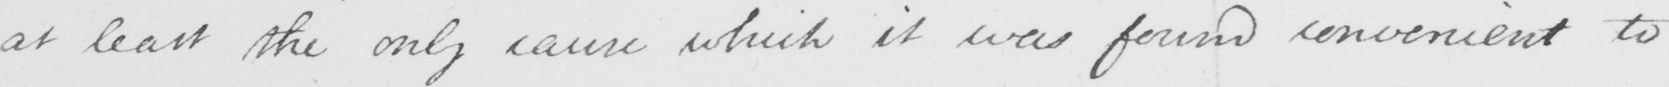Transcribe the text shown in this historical manuscript line. at least the only cause which it was found convenient to 